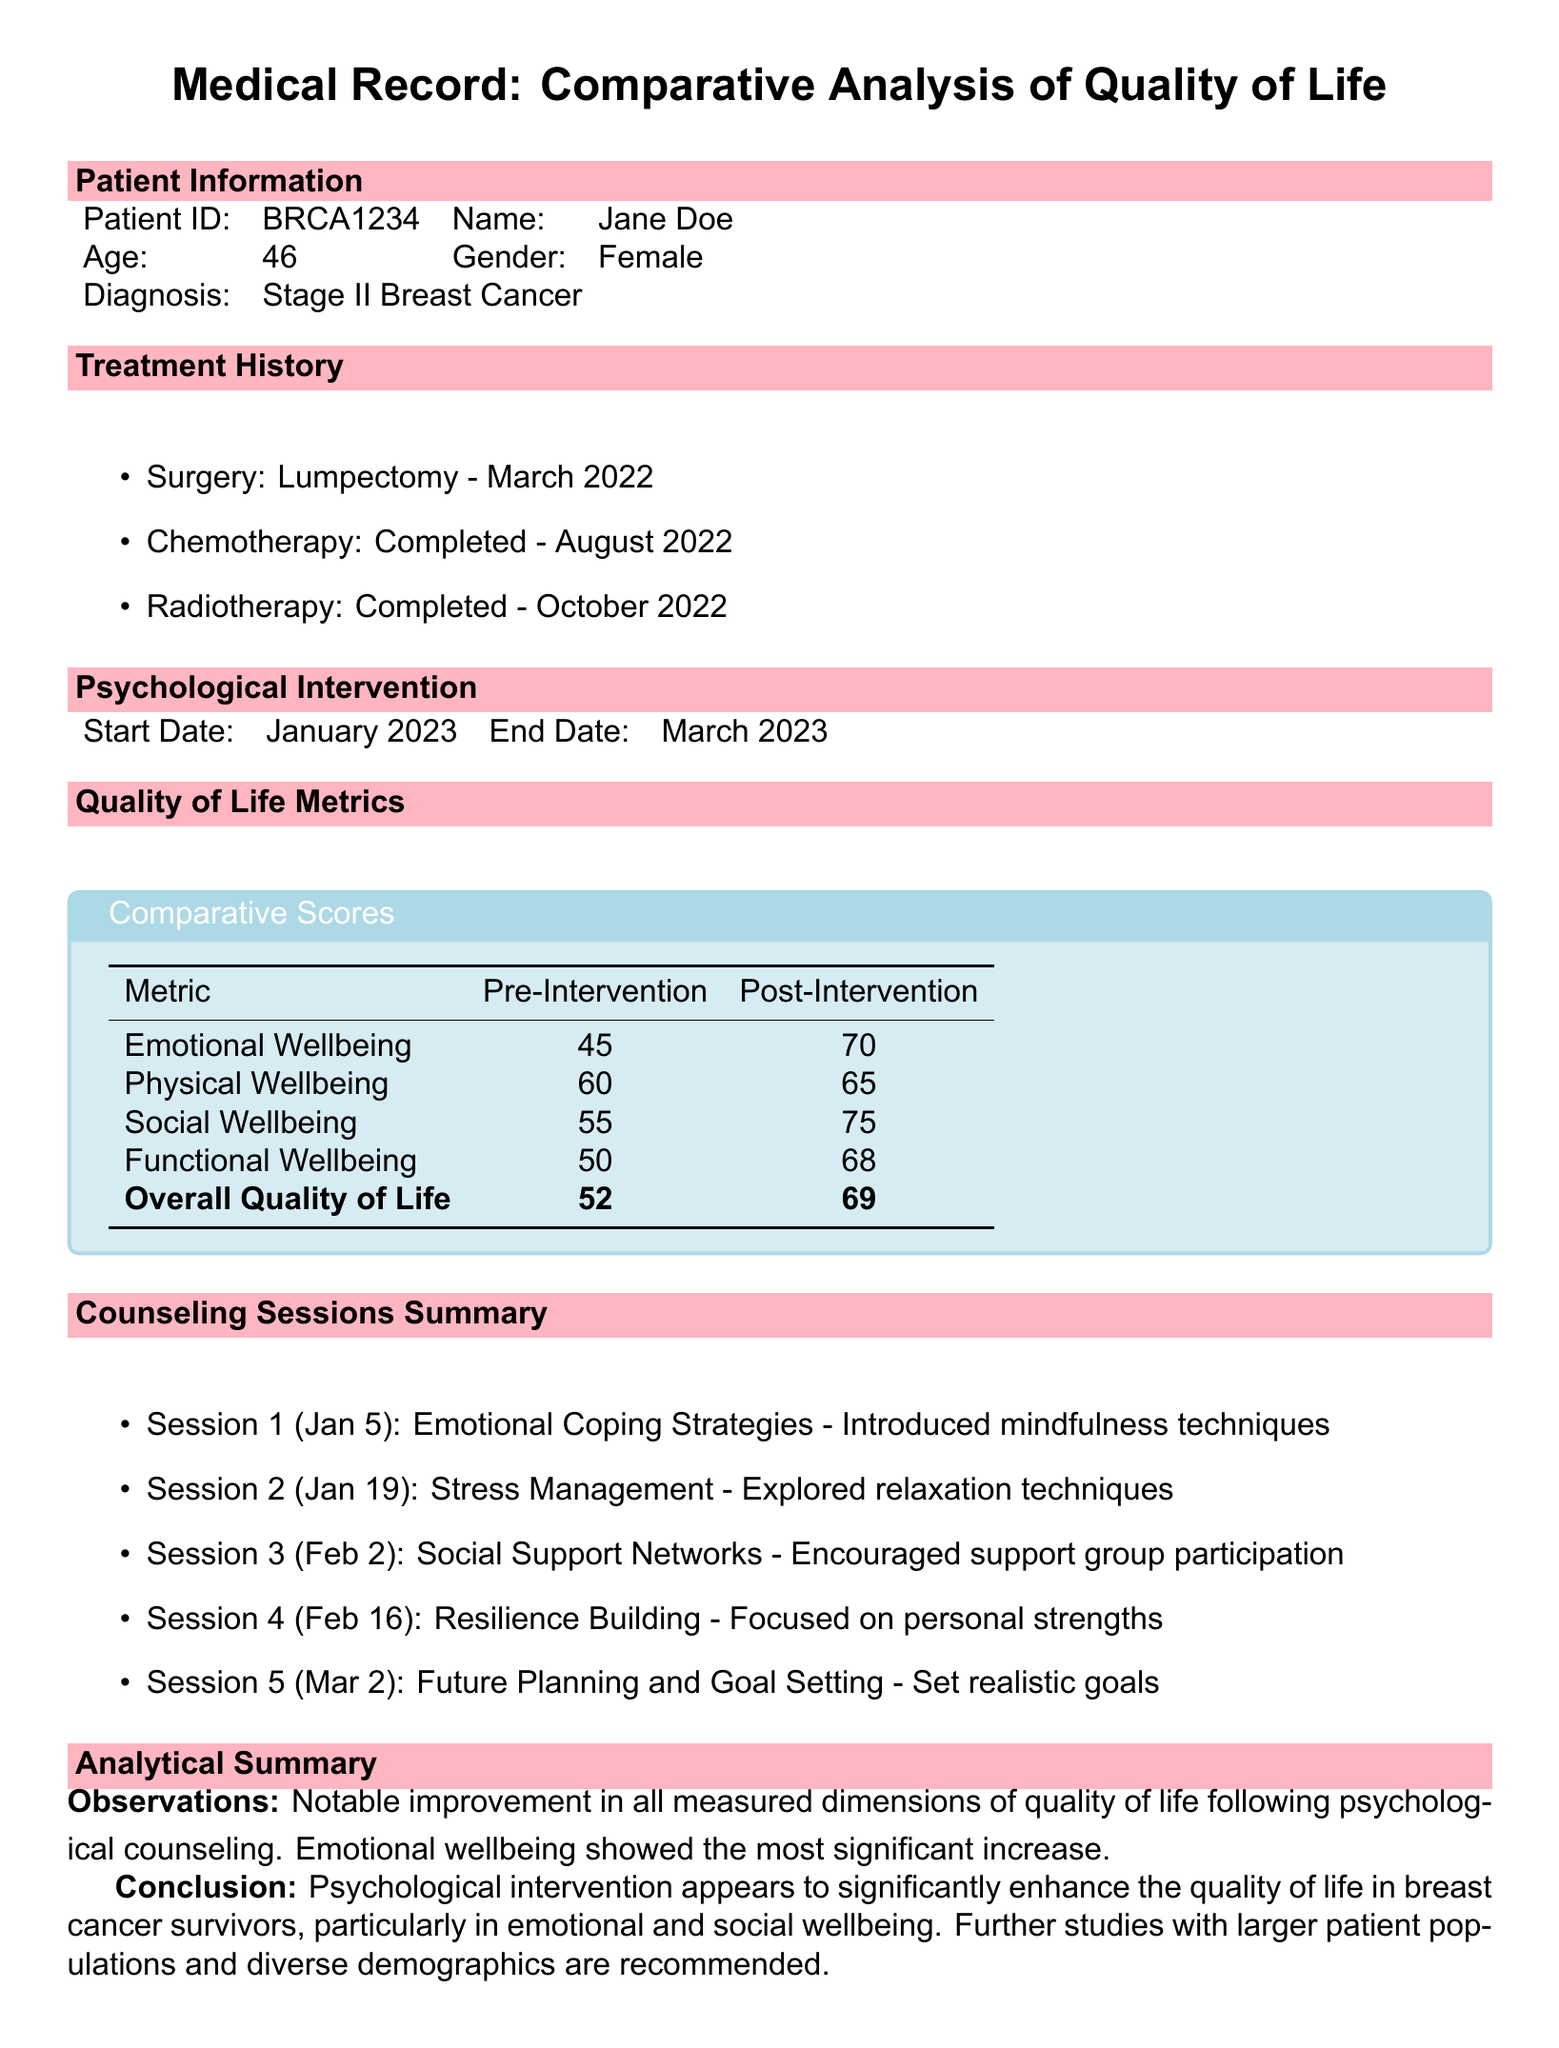What is the patient's name? The patient's name is provided in the Patient Information section of the document.
Answer: Jane Doe What was the patient's age at diagnosis? The age of the patient is mentioned in the Patient Information section.
Answer: 46 What was the overall quality of life score before intervention? The score is listed in the Quality of Life Metrics section.
Answer: 52 How many counseling sessions were conducted? The number of sessions can be counted from the Counseling Sessions Summary section.
Answer: 5 What is the date range of the psychological intervention? The start and end dates of the intervention are listed in the Psychological Intervention section.
Answer: January 2023 - March 2023 Which wellbeing metric showed the most significant increase after intervention? The Observations in the Analytical Summary mention which metric had the highest improvement.
Answer: Emotional wellbeing What was the patient's diagnosis? The diagnosis is stated in the Patient Information section.
Answer: Stage II Breast Cancer What technique was introduced in the first session? The first session's focus is described in the Counseling Sessions Summary section.
Answer: Mindfulness techniques What is the patient's gender? The gender of the patient is provided in the Patient Information section.
Answer: Female 